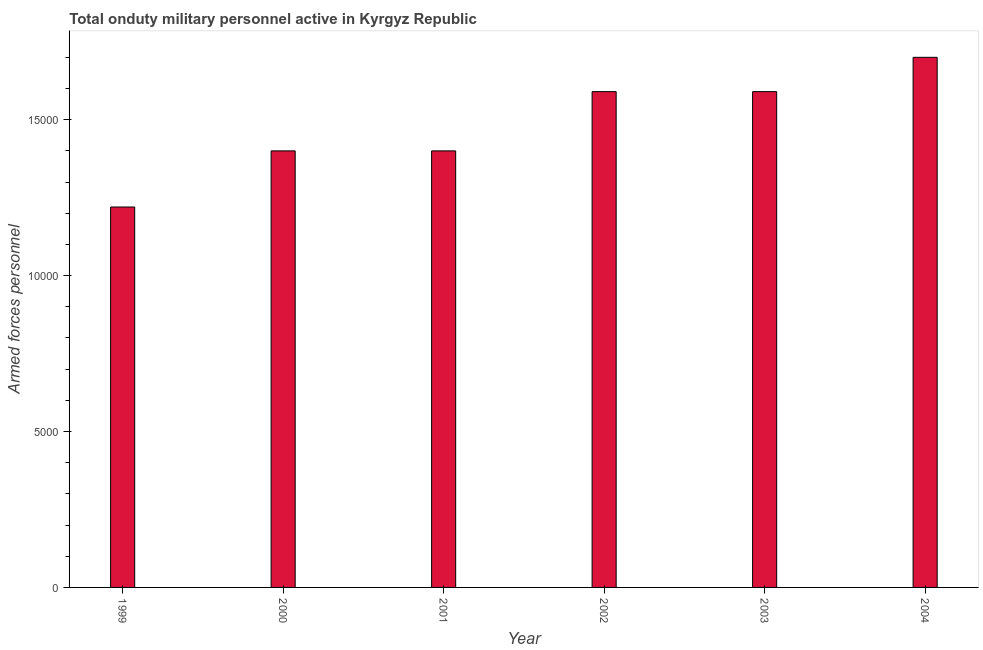Does the graph contain grids?
Offer a terse response. No. What is the title of the graph?
Your answer should be compact. Total onduty military personnel active in Kyrgyz Republic. What is the label or title of the X-axis?
Your answer should be compact. Year. What is the label or title of the Y-axis?
Keep it short and to the point. Armed forces personnel. What is the number of armed forces personnel in 2001?
Make the answer very short. 1.40e+04. Across all years, what is the maximum number of armed forces personnel?
Provide a succinct answer. 1.70e+04. Across all years, what is the minimum number of armed forces personnel?
Your answer should be compact. 1.22e+04. In which year was the number of armed forces personnel maximum?
Your answer should be very brief. 2004. In which year was the number of armed forces personnel minimum?
Offer a very short reply. 1999. What is the sum of the number of armed forces personnel?
Your answer should be very brief. 8.90e+04. What is the difference between the number of armed forces personnel in 1999 and 2000?
Offer a terse response. -1800. What is the average number of armed forces personnel per year?
Your response must be concise. 1.48e+04. What is the median number of armed forces personnel?
Offer a very short reply. 1.50e+04. In how many years, is the number of armed forces personnel greater than 14000 ?
Your response must be concise. 3. What is the difference between the highest and the second highest number of armed forces personnel?
Offer a very short reply. 1100. Is the sum of the number of armed forces personnel in 1999 and 2001 greater than the maximum number of armed forces personnel across all years?
Provide a short and direct response. Yes. What is the difference between the highest and the lowest number of armed forces personnel?
Your answer should be very brief. 4800. In how many years, is the number of armed forces personnel greater than the average number of armed forces personnel taken over all years?
Offer a very short reply. 3. What is the Armed forces personnel in 1999?
Provide a short and direct response. 1.22e+04. What is the Armed forces personnel of 2000?
Offer a very short reply. 1.40e+04. What is the Armed forces personnel in 2001?
Give a very brief answer. 1.40e+04. What is the Armed forces personnel of 2002?
Your answer should be compact. 1.59e+04. What is the Armed forces personnel of 2003?
Ensure brevity in your answer.  1.59e+04. What is the Armed forces personnel of 2004?
Provide a succinct answer. 1.70e+04. What is the difference between the Armed forces personnel in 1999 and 2000?
Give a very brief answer. -1800. What is the difference between the Armed forces personnel in 1999 and 2001?
Offer a very short reply. -1800. What is the difference between the Armed forces personnel in 1999 and 2002?
Give a very brief answer. -3700. What is the difference between the Armed forces personnel in 1999 and 2003?
Make the answer very short. -3700. What is the difference between the Armed forces personnel in 1999 and 2004?
Your response must be concise. -4800. What is the difference between the Armed forces personnel in 2000 and 2002?
Your response must be concise. -1900. What is the difference between the Armed forces personnel in 2000 and 2003?
Ensure brevity in your answer.  -1900. What is the difference between the Armed forces personnel in 2000 and 2004?
Your response must be concise. -3000. What is the difference between the Armed forces personnel in 2001 and 2002?
Your response must be concise. -1900. What is the difference between the Armed forces personnel in 2001 and 2003?
Give a very brief answer. -1900. What is the difference between the Armed forces personnel in 2001 and 2004?
Provide a succinct answer. -3000. What is the difference between the Armed forces personnel in 2002 and 2004?
Ensure brevity in your answer.  -1100. What is the difference between the Armed forces personnel in 2003 and 2004?
Give a very brief answer. -1100. What is the ratio of the Armed forces personnel in 1999 to that in 2000?
Offer a very short reply. 0.87. What is the ratio of the Armed forces personnel in 1999 to that in 2001?
Your response must be concise. 0.87. What is the ratio of the Armed forces personnel in 1999 to that in 2002?
Your answer should be very brief. 0.77. What is the ratio of the Armed forces personnel in 1999 to that in 2003?
Offer a very short reply. 0.77. What is the ratio of the Armed forces personnel in 1999 to that in 2004?
Your response must be concise. 0.72. What is the ratio of the Armed forces personnel in 2000 to that in 2002?
Provide a short and direct response. 0.88. What is the ratio of the Armed forces personnel in 2000 to that in 2003?
Offer a terse response. 0.88. What is the ratio of the Armed forces personnel in 2000 to that in 2004?
Keep it short and to the point. 0.82. What is the ratio of the Armed forces personnel in 2001 to that in 2002?
Your response must be concise. 0.88. What is the ratio of the Armed forces personnel in 2001 to that in 2003?
Provide a short and direct response. 0.88. What is the ratio of the Armed forces personnel in 2001 to that in 2004?
Offer a terse response. 0.82. What is the ratio of the Armed forces personnel in 2002 to that in 2004?
Ensure brevity in your answer.  0.94. What is the ratio of the Armed forces personnel in 2003 to that in 2004?
Make the answer very short. 0.94. 